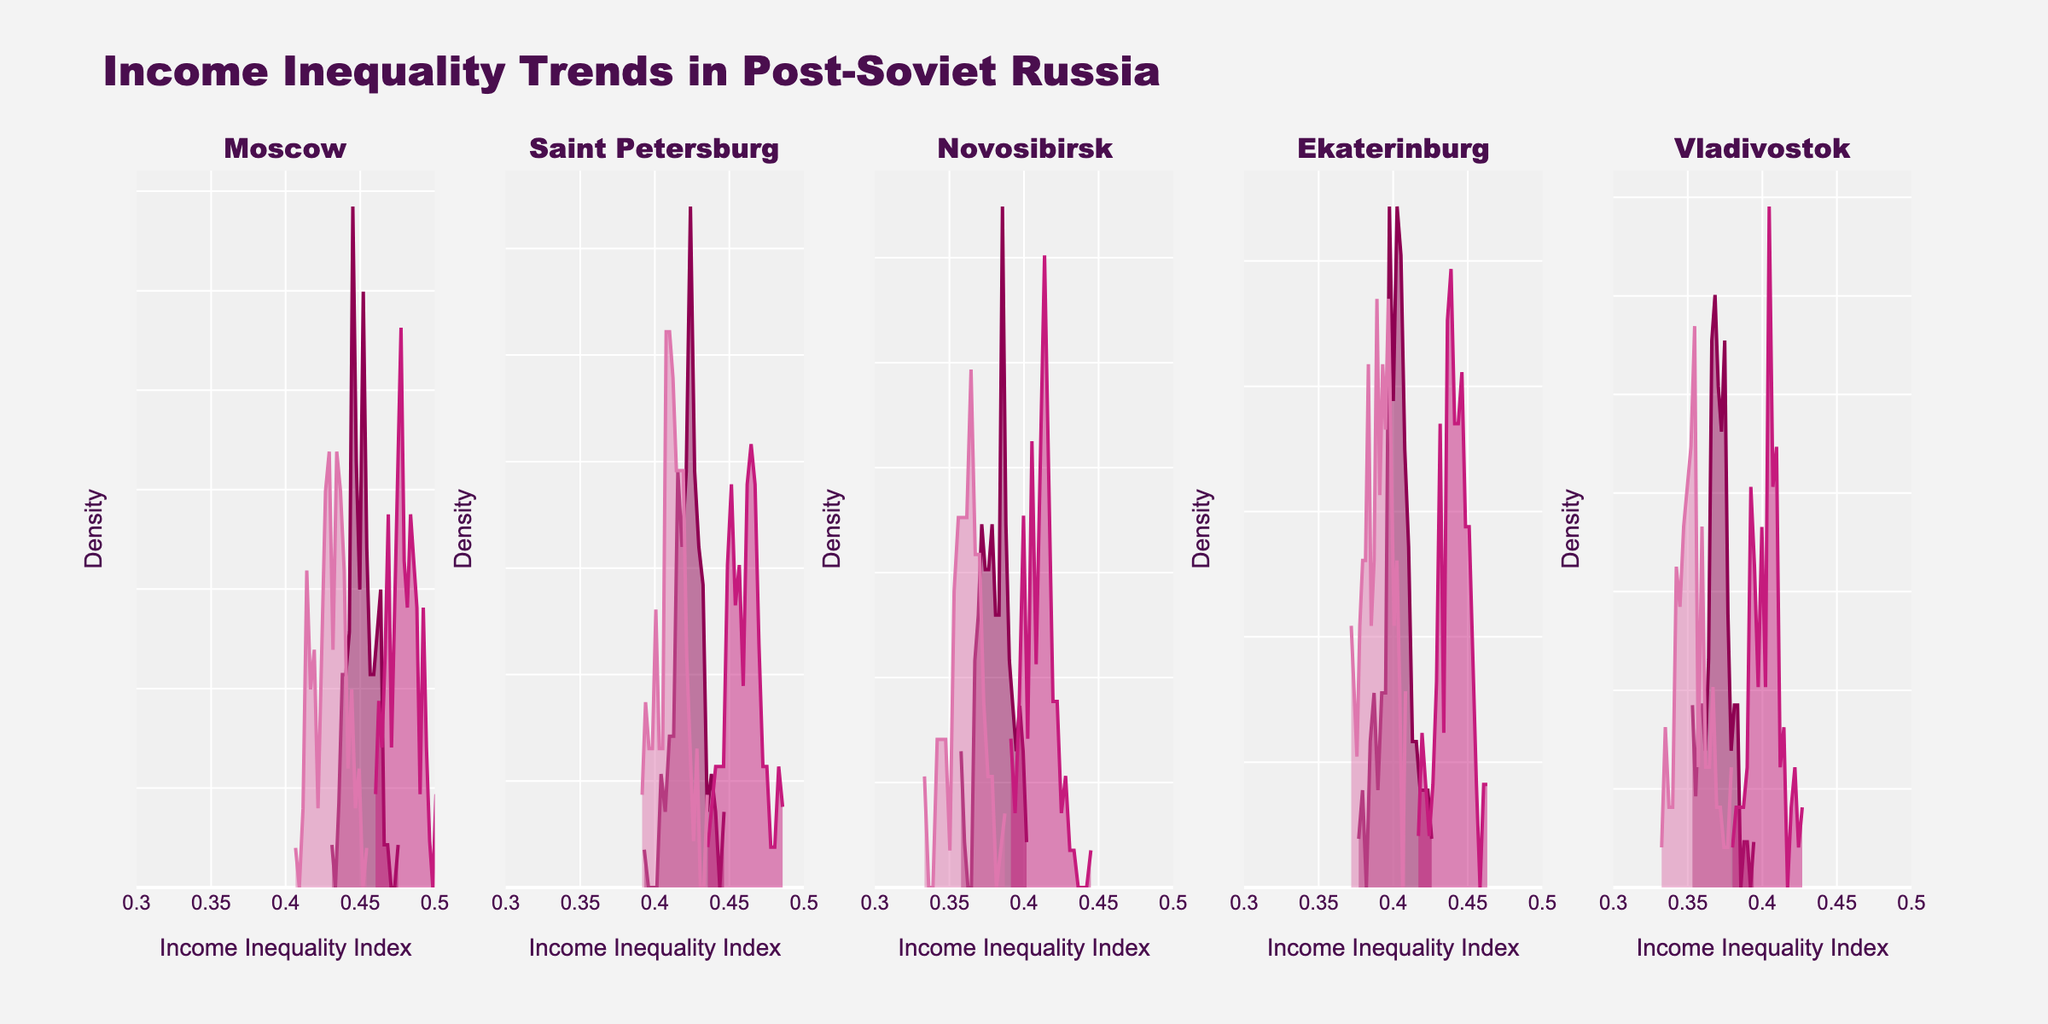What is the title of the figure? The title is displayed at the top of the figure. It reads "Income Inequality Trends in Post-Soviet Russia."
Answer: Income Inequality Trends in Post-Soviet Russia How many regions are there in the figure? Each subplot title corresponds to a region. Count the number of subplot titles to determine the number of regions. There are five subplot titles: "Moscow," "Saint Petersburg," "Novosibirsk," "Ekaterinburg," and "Vladivostok."
Answer: Five Which color is used for the year 1992 in the density plot? Each year has a unique color. By looking at the different colors in the density plots and matching them with the year labels, we see that 1992 is represented by the darkest color, which is a deep reddish-burgundy.
Answer: Deep red-burgundy In Moscow, how does the Income Inequality Index trend change from 1992 to 2000? The density plot for Moscow shows different curves for each year. Observing the peak positions and distributions in 1992, 1995, and 2000, we notice that the peak (majority value) decreases from 1995 to 2000 but is slightly lower in 1992.
Answer: Decreases Which region shows the lowest Income Inequality Index in the year 2000? Inspect all subplots, specifically looking at the density plots for the year 2000 and identifying the peak positions. The density plot for Vladivostok in 2000 has the lowest peak position among all the regions.
Answer: Vladivostok What is the approximate range of the Income Inequality Index displayed in the figure? The x-axis of each subplot, labeled "Income Inequality Index," shows the range. By examining the figure, you can see that it ranges from about 0.3 to 0.5.
Answer: 0.3 to 0.5 How does the distribution of Income Inequality Index in Saint Petersburg change between 1992 and 1995? Looking at the density plots for Saint Petersburg in 1992 and 1995, we see that the peak shifts higher in 1995 compared to 1992, indicating an increase in income inequality.
Answer: Increases Compare the Income Inequality Index peaks between Novosibirsk in 1992 and Ekaterinburg in 1995. Which one is higher? Examine the density plots for Novosibirsk in 1992 and Ekaterinburg in 1995. The peak position in Ekaterinburg 1995 is higher than that in Novosibirsk 1992.
Answer: Ekaterinburg in 1995 What year shows the highest Income Inequality Index in Saint Petersburg? Refer to the density plots of Saint Petersburg for the years 1992, 1995, and 2000. The highest peak is in 1995, indicating the highest Income Inequality Index in that year.
Answer: 1995 